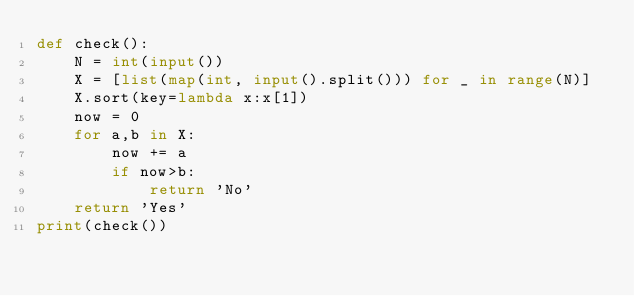Convert code to text. <code><loc_0><loc_0><loc_500><loc_500><_Python_>def check():
    N = int(input())
    X = [list(map(int, input().split())) for _ in range(N)]
    X.sort(key=lambda x:x[1])
    now = 0
    for a,b in X:
        now += a
        if now>b:
            return 'No'
    return 'Yes'
print(check())</code> 